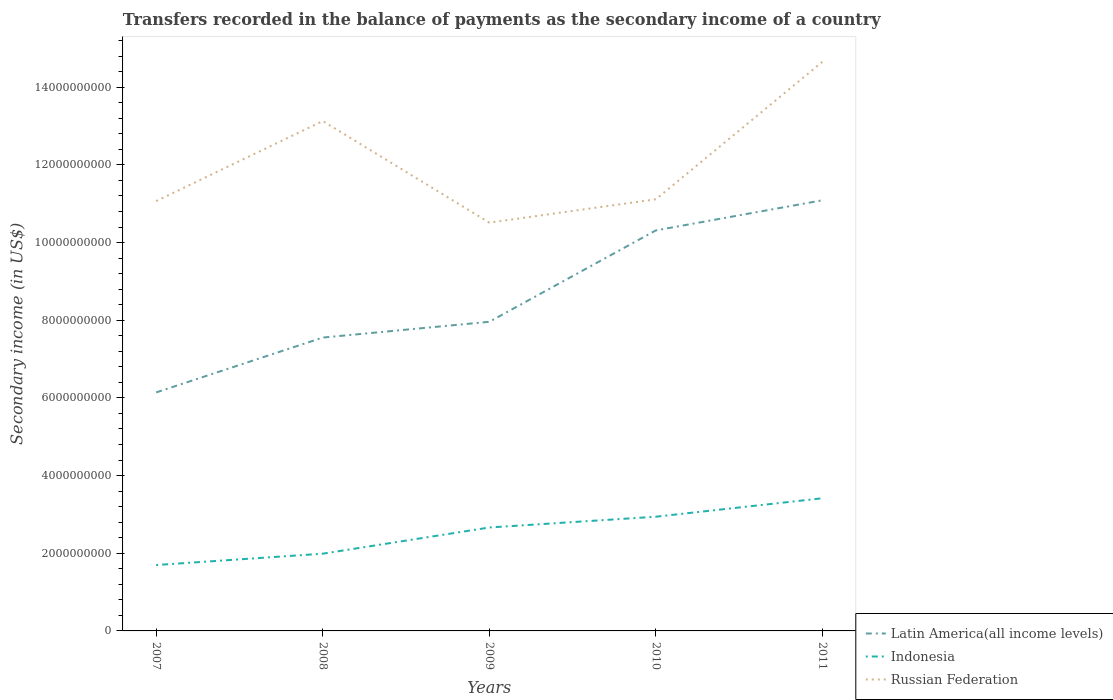Does the line corresponding to Indonesia intersect with the line corresponding to Latin America(all income levels)?
Ensure brevity in your answer.  No. Across all years, what is the maximum secondary income of in Latin America(all income levels)?
Ensure brevity in your answer.  6.14e+09. What is the total secondary income of in Indonesia in the graph?
Ensure brevity in your answer.  -9.67e+08. What is the difference between the highest and the second highest secondary income of in Russian Federation?
Your response must be concise. 4.14e+09. What is the difference between the highest and the lowest secondary income of in Indonesia?
Ensure brevity in your answer.  3. Is the secondary income of in Latin America(all income levels) strictly greater than the secondary income of in Russian Federation over the years?
Ensure brevity in your answer.  Yes. How many years are there in the graph?
Your answer should be very brief. 5. What is the title of the graph?
Offer a terse response. Transfers recorded in the balance of payments as the secondary income of a country. What is the label or title of the X-axis?
Ensure brevity in your answer.  Years. What is the label or title of the Y-axis?
Keep it short and to the point. Secondary income (in US$). What is the Secondary income (in US$) of Latin America(all income levels) in 2007?
Ensure brevity in your answer.  6.14e+09. What is the Secondary income (in US$) in Indonesia in 2007?
Provide a short and direct response. 1.70e+09. What is the Secondary income (in US$) in Russian Federation in 2007?
Offer a very short reply. 1.11e+1. What is the Secondary income (in US$) of Latin America(all income levels) in 2008?
Your response must be concise. 7.55e+09. What is the Secondary income (in US$) of Indonesia in 2008?
Ensure brevity in your answer.  1.99e+09. What is the Secondary income (in US$) of Russian Federation in 2008?
Offer a very short reply. 1.31e+1. What is the Secondary income (in US$) in Latin America(all income levels) in 2009?
Offer a terse response. 7.96e+09. What is the Secondary income (in US$) in Indonesia in 2009?
Your answer should be very brief. 2.66e+09. What is the Secondary income (in US$) of Russian Federation in 2009?
Your answer should be very brief. 1.05e+1. What is the Secondary income (in US$) in Latin America(all income levels) in 2010?
Provide a short and direct response. 1.03e+1. What is the Secondary income (in US$) of Indonesia in 2010?
Your response must be concise. 2.94e+09. What is the Secondary income (in US$) of Russian Federation in 2010?
Offer a very short reply. 1.11e+1. What is the Secondary income (in US$) of Latin America(all income levels) in 2011?
Provide a succinct answer. 1.11e+1. What is the Secondary income (in US$) in Indonesia in 2011?
Offer a very short reply. 3.42e+09. What is the Secondary income (in US$) of Russian Federation in 2011?
Offer a terse response. 1.47e+1. Across all years, what is the maximum Secondary income (in US$) of Latin America(all income levels)?
Keep it short and to the point. 1.11e+1. Across all years, what is the maximum Secondary income (in US$) of Indonesia?
Provide a succinct answer. 3.42e+09. Across all years, what is the maximum Secondary income (in US$) of Russian Federation?
Your answer should be compact. 1.47e+1. Across all years, what is the minimum Secondary income (in US$) of Latin America(all income levels)?
Your answer should be very brief. 6.14e+09. Across all years, what is the minimum Secondary income (in US$) in Indonesia?
Keep it short and to the point. 1.70e+09. Across all years, what is the minimum Secondary income (in US$) of Russian Federation?
Keep it short and to the point. 1.05e+1. What is the total Secondary income (in US$) of Latin America(all income levels) in the graph?
Provide a succinct answer. 4.31e+1. What is the total Secondary income (in US$) in Indonesia in the graph?
Ensure brevity in your answer.  1.27e+1. What is the total Secondary income (in US$) of Russian Federation in the graph?
Offer a terse response. 6.05e+1. What is the difference between the Secondary income (in US$) in Latin America(all income levels) in 2007 and that in 2008?
Your response must be concise. -1.41e+09. What is the difference between the Secondary income (in US$) in Indonesia in 2007 and that in 2008?
Provide a succinct answer. -2.92e+08. What is the difference between the Secondary income (in US$) in Russian Federation in 2007 and that in 2008?
Make the answer very short. -2.06e+09. What is the difference between the Secondary income (in US$) of Latin America(all income levels) in 2007 and that in 2009?
Provide a short and direct response. -1.82e+09. What is the difference between the Secondary income (in US$) of Indonesia in 2007 and that in 2009?
Provide a short and direct response. -9.67e+08. What is the difference between the Secondary income (in US$) of Russian Federation in 2007 and that in 2009?
Your response must be concise. 5.55e+08. What is the difference between the Secondary income (in US$) of Latin America(all income levels) in 2007 and that in 2010?
Your answer should be very brief. -4.17e+09. What is the difference between the Secondary income (in US$) of Indonesia in 2007 and that in 2010?
Offer a terse response. -1.24e+09. What is the difference between the Secondary income (in US$) in Russian Federation in 2007 and that in 2010?
Provide a short and direct response. -4.65e+07. What is the difference between the Secondary income (in US$) of Latin America(all income levels) in 2007 and that in 2011?
Ensure brevity in your answer.  -4.95e+09. What is the difference between the Secondary income (in US$) in Indonesia in 2007 and that in 2011?
Your answer should be very brief. -1.72e+09. What is the difference between the Secondary income (in US$) in Russian Federation in 2007 and that in 2011?
Offer a very short reply. -3.59e+09. What is the difference between the Secondary income (in US$) of Latin America(all income levels) in 2008 and that in 2009?
Offer a terse response. -4.06e+08. What is the difference between the Secondary income (in US$) in Indonesia in 2008 and that in 2009?
Provide a short and direct response. -6.75e+08. What is the difference between the Secondary income (in US$) in Russian Federation in 2008 and that in 2009?
Your response must be concise. 2.62e+09. What is the difference between the Secondary income (in US$) of Latin America(all income levels) in 2008 and that in 2010?
Offer a terse response. -2.76e+09. What is the difference between the Secondary income (in US$) in Indonesia in 2008 and that in 2010?
Offer a very short reply. -9.52e+08. What is the difference between the Secondary income (in US$) in Russian Federation in 2008 and that in 2010?
Your answer should be very brief. 2.01e+09. What is the difference between the Secondary income (in US$) of Latin America(all income levels) in 2008 and that in 2011?
Provide a succinct answer. -3.54e+09. What is the difference between the Secondary income (in US$) in Indonesia in 2008 and that in 2011?
Your answer should be compact. -1.43e+09. What is the difference between the Secondary income (in US$) of Russian Federation in 2008 and that in 2011?
Your answer should be very brief. -1.53e+09. What is the difference between the Secondary income (in US$) in Latin America(all income levels) in 2009 and that in 2010?
Offer a very short reply. -2.35e+09. What is the difference between the Secondary income (in US$) in Indonesia in 2009 and that in 2010?
Ensure brevity in your answer.  -2.78e+08. What is the difference between the Secondary income (in US$) in Russian Federation in 2009 and that in 2010?
Offer a terse response. -6.02e+08. What is the difference between the Secondary income (in US$) of Latin America(all income levels) in 2009 and that in 2011?
Give a very brief answer. -3.13e+09. What is the difference between the Secondary income (in US$) in Indonesia in 2009 and that in 2011?
Ensure brevity in your answer.  -7.53e+08. What is the difference between the Secondary income (in US$) in Russian Federation in 2009 and that in 2011?
Make the answer very short. -4.14e+09. What is the difference between the Secondary income (in US$) in Latin America(all income levels) in 2010 and that in 2011?
Offer a terse response. -7.75e+08. What is the difference between the Secondary income (in US$) of Indonesia in 2010 and that in 2011?
Your answer should be compact. -4.75e+08. What is the difference between the Secondary income (in US$) in Russian Federation in 2010 and that in 2011?
Keep it short and to the point. -3.54e+09. What is the difference between the Secondary income (in US$) in Latin America(all income levels) in 2007 and the Secondary income (in US$) in Indonesia in 2008?
Your response must be concise. 4.15e+09. What is the difference between the Secondary income (in US$) of Latin America(all income levels) in 2007 and the Secondary income (in US$) of Russian Federation in 2008?
Your answer should be compact. -6.99e+09. What is the difference between the Secondary income (in US$) in Indonesia in 2007 and the Secondary income (in US$) in Russian Federation in 2008?
Give a very brief answer. -1.14e+1. What is the difference between the Secondary income (in US$) in Latin America(all income levels) in 2007 and the Secondary income (in US$) in Indonesia in 2009?
Offer a terse response. 3.48e+09. What is the difference between the Secondary income (in US$) in Latin America(all income levels) in 2007 and the Secondary income (in US$) in Russian Federation in 2009?
Give a very brief answer. -4.37e+09. What is the difference between the Secondary income (in US$) in Indonesia in 2007 and the Secondary income (in US$) in Russian Federation in 2009?
Your answer should be compact. -8.82e+09. What is the difference between the Secondary income (in US$) of Latin America(all income levels) in 2007 and the Secondary income (in US$) of Indonesia in 2010?
Give a very brief answer. 3.20e+09. What is the difference between the Secondary income (in US$) in Latin America(all income levels) in 2007 and the Secondary income (in US$) in Russian Federation in 2010?
Ensure brevity in your answer.  -4.97e+09. What is the difference between the Secondary income (in US$) of Indonesia in 2007 and the Secondary income (in US$) of Russian Federation in 2010?
Provide a short and direct response. -9.42e+09. What is the difference between the Secondary income (in US$) in Latin America(all income levels) in 2007 and the Secondary income (in US$) in Indonesia in 2011?
Your answer should be compact. 2.73e+09. What is the difference between the Secondary income (in US$) in Latin America(all income levels) in 2007 and the Secondary income (in US$) in Russian Federation in 2011?
Offer a very short reply. -8.51e+09. What is the difference between the Secondary income (in US$) of Indonesia in 2007 and the Secondary income (in US$) of Russian Federation in 2011?
Provide a succinct answer. -1.30e+1. What is the difference between the Secondary income (in US$) of Latin America(all income levels) in 2008 and the Secondary income (in US$) of Indonesia in 2009?
Your answer should be compact. 4.89e+09. What is the difference between the Secondary income (in US$) in Latin America(all income levels) in 2008 and the Secondary income (in US$) in Russian Federation in 2009?
Your answer should be compact. -2.96e+09. What is the difference between the Secondary income (in US$) of Indonesia in 2008 and the Secondary income (in US$) of Russian Federation in 2009?
Offer a very short reply. -8.52e+09. What is the difference between the Secondary income (in US$) of Latin America(all income levels) in 2008 and the Secondary income (in US$) of Indonesia in 2010?
Give a very brief answer. 4.61e+09. What is the difference between the Secondary income (in US$) in Latin America(all income levels) in 2008 and the Secondary income (in US$) in Russian Federation in 2010?
Your response must be concise. -3.56e+09. What is the difference between the Secondary income (in US$) of Indonesia in 2008 and the Secondary income (in US$) of Russian Federation in 2010?
Give a very brief answer. -9.13e+09. What is the difference between the Secondary income (in US$) of Latin America(all income levels) in 2008 and the Secondary income (in US$) of Indonesia in 2011?
Provide a succinct answer. 4.14e+09. What is the difference between the Secondary income (in US$) of Latin America(all income levels) in 2008 and the Secondary income (in US$) of Russian Federation in 2011?
Provide a short and direct response. -7.10e+09. What is the difference between the Secondary income (in US$) of Indonesia in 2008 and the Secondary income (in US$) of Russian Federation in 2011?
Keep it short and to the point. -1.27e+1. What is the difference between the Secondary income (in US$) of Latin America(all income levels) in 2009 and the Secondary income (in US$) of Indonesia in 2010?
Your response must be concise. 5.02e+09. What is the difference between the Secondary income (in US$) in Latin America(all income levels) in 2009 and the Secondary income (in US$) in Russian Federation in 2010?
Offer a terse response. -3.15e+09. What is the difference between the Secondary income (in US$) of Indonesia in 2009 and the Secondary income (in US$) of Russian Federation in 2010?
Your answer should be very brief. -8.45e+09. What is the difference between the Secondary income (in US$) of Latin America(all income levels) in 2009 and the Secondary income (in US$) of Indonesia in 2011?
Provide a succinct answer. 4.54e+09. What is the difference between the Secondary income (in US$) of Latin America(all income levels) in 2009 and the Secondary income (in US$) of Russian Federation in 2011?
Your answer should be very brief. -6.70e+09. What is the difference between the Secondary income (in US$) of Indonesia in 2009 and the Secondary income (in US$) of Russian Federation in 2011?
Make the answer very short. -1.20e+1. What is the difference between the Secondary income (in US$) of Latin America(all income levels) in 2010 and the Secondary income (in US$) of Indonesia in 2011?
Offer a very short reply. 6.90e+09. What is the difference between the Secondary income (in US$) of Latin America(all income levels) in 2010 and the Secondary income (in US$) of Russian Federation in 2011?
Offer a terse response. -4.34e+09. What is the difference between the Secondary income (in US$) of Indonesia in 2010 and the Secondary income (in US$) of Russian Federation in 2011?
Offer a very short reply. -1.17e+1. What is the average Secondary income (in US$) in Latin America(all income levels) per year?
Make the answer very short. 8.61e+09. What is the average Secondary income (in US$) in Indonesia per year?
Provide a short and direct response. 2.54e+09. What is the average Secondary income (in US$) of Russian Federation per year?
Offer a very short reply. 1.21e+1. In the year 2007, what is the difference between the Secondary income (in US$) of Latin America(all income levels) and Secondary income (in US$) of Indonesia?
Ensure brevity in your answer.  4.44e+09. In the year 2007, what is the difference between the Secondary income (in US$) of Latin America(all income levels) and Secondary income (in US$) of Russian Federation?
Your answer should be compact. -4.93e+09. In the year 2007, what is the difference between the Secondary income (in US$) in Indonesia and Secondary income (in US$) in Russian Federation?
Your answer should be compact. -9.37e+09. In the year 2008, what is the difference between the Secondary income (in US$) in Latin America(all income levels) and Secondary income (in US$) in Indonesia?
Give a very brief answer. 5.56e+09. In the year 2008, what is the difference between the Secondary income (in US$) of Latin America(all income levels) and Secondary income (in US$) of Russian Federation?
Provide a short and direct response. -5.57e+09. In the year 2008, what is the difference between the Secondary income (in US$) of Indonesia and Secondary income (in US$) of Russian Federation?
Make the answer very short. -1.11e+1. In the year 2009, what is the difference between the Secondary income (in US$) in Latin America(all income levels) and Secondary income (in US$) in Indonesia?
Offer a terse response. 5.30e+09. In the year 2009, what is the difference between the Secondary income (in US$) of Latin America(all income levels) and Secondary income (in US$) of Russian Federation?
Give a very brief answer. -2.55e+09. In the year 2009, what is the difference between the Secondary income (in US$) of Indonesia and Secondary income (in US$) of Russian Federation?
Offer a very short reply. -7.85e+09. In the year 2010, what is the difference between the Secondary income (in US$) in Latin America(all income levels) and Secondary income (in US$) in Indonesia?
Provide a succinct answer. 7.37e+09. In the year 2010, what is the difference between the Secondary income (in US$) in Latin America(all income levels) and Secondary income (in US$) in Russian Federation?
Offer a terse response. -8.01e+08. In the year 2010, what is the difference between the Secondary income (in US$) of Indonesia and Secondary income (in US$) of Russian Federation?
Your response must be concise. -8.17e+09. In the year 2011, what is the difference between the Secondary income (in US$) of Latin America(all income levels) and Secondary income (in US$) of Indonesia?
Ensure brevity in your answer.  7.67e+09. In the year 2011, what is the difference between the Secondary income (in US$) in Latin America(all income levels) and Secondary income (in US$) in Russian Federation?
Give a very brief answer. -3.57e+09. In the year 2011, what is the difference between the Secondary income (in US$) of Indonesia and Secondary income (in US$) of Russian Federation?
Your response must be concise. -1.12e+1. What is the ratio of the Secondary income (in US$) in Latin America(all income levels) in 2007 to that in 2008?
Your answer should be compact. 0.81. What is the ratio of the Secondary income (in US$) of Indonesia in 2007 to that in 2008?
Your answer should be very brief. 0.85. What is the ratio of the Secondary income (in US$) in Russian Federation in 2007 to that in 2008?
Provide a short and direct response. 0.84. What is the ratio of the Secondary income (in US$) of Latin America(all income levels) in 2007 to that in 2009?
Provide a short and direct response. 0.77. What is the ratio of the Secondary income (in US$) of Indonesia in 2007 to that in 2009?
Keep it short and to the point. 0.64. What is the ratio of the Secondary income (in US$) in Russian Federation in 2007 to that in 2009?
Give a very brief answer. 1.05. What is the ratio of the Secondary income (in US$) of Latin America(all income levels) in 2007 to that in 2010?
Your answer should be very brief. 0.6. What is the ratio of the Secondary income (in US$) of Indonesia in 2007 to that in 2010?
Your response must be concise. 0.58. What is the ratio of the Secondary income (in US$) of Latin America(all income levels) in 2007 to that in 2011?
Ensure brevity in your answer.  0.55. What is the ratio of the Secondary income (in US$) in Indonesia in 2007 to that in 2011?
Give a very brief answer. 0.5. What is the ratio of the Secondary income (in US$) in Russian Federation in 2007 to that in 2011?
Give a very brief answer. 0.76. What is the ratio of the Secondary income (in US$) of Latin America(all income levels) in 2008 to that in 2009?
Provide a succinct answer. 0.95. What is the ratio of the Secondary income (in US$) of Indonesia in 2008 to that in 2009?
Your response must be concise. 0.75. What is the ratio of the Secondary income (in US$) in Russian Federation in 2008 to that in 2009?
Provide a succinct answer. 1.25. What is the ratio of the Secondary income (in US$) in Latin America(all income levels) in 2008 to that in 2010?
Provide a short and direct response. 0.73. What is the ratio of the Secondary income (in US$) of Indonesia in 2008 to that in 2010?
Ensure brevity in your answer.  0.68. What is the ratio of the Secondary income (in US$) in Russian Federation in 2008 to that in 2010?
Provide a succinct answer. 1.18. What is the ratio of the Secondary income (in US$) in Latin America(all income levels) in 2008 to that in 2011?
Make the answer very short. 0.68. What is the ratio of the Secondary income (in US$) in Indonesia in 2008 to that in 2011?
Your answer should be very brief. 0.58. What is the ratio of the Secondary income (in US$) in Russian Federation in 2008 to that in 2011?
Make the answer very short. 0.9. What is the ratio of the Secondary income (in US$) in Latin America(all income levels) in 2009 to that in 2010?
Ensure brevity in your answer.  0.77. What is the ratio of the Secondary income (in US$) of Indonesia in 2009 to that in 2010?
Provide a short and direct response. 0.91. What is the ratio of the Secondary income (in US$) in Russian Federation in 2009 to that in 2010?
Ensure brevity in your answer.  0.95. What is the ratio of the Secondary income (in US$) in Latin America(all income levels) in 2009 to that in 2011?
Provide a short and direct response. 0.72. What is the ratio of the Secondary income (in US$) of Indonesia in 2009 to that in 2011?
Provide a short and direct response. 0.78. What is the ratio of the Secondary income (in US$) in Russian Federation in 2009 to that in 2011?
Your answer should be compact. 0.72. What is the ratio of the Secondary income (in US$) in Latin America(all income levels) in 2010 to that in 2011?
Your response must be concise. 0.93. What is the ratio of the Secondary income (in US$) of Indonesia in 2010 to that in 2011?
Ensure brevity in your answer.  0.86. What is the ratio of the Secondary income (in US$) of Russian Federation in 2010 to that in 2011?
Your answer should be compact. 0.76. What is the difference between the highest and the second highest Secondary income (in US$) in Latin America(all income levels)?
Provide a succinct answer. 7.75e+08. What is the difference between the highest and the second highest Secondary income (in US$) of Indonesia?
Provide a short and direct response. 4.75e+08. What is the difference between the highest and the second highest Secondary income (in US$) of Russian Federation?
Keep it short and to the point. 1.53e+09. What is the difference between the highest and the lowest Secondary income (in US$) of Latin America(all income levels)?
Your response must be concise. 4.95e+09. What is the difference between the highest and the lowest Secondary income (in US$) in Indonesia?
Provide a short and direct response. 1.72e+09. What is the difference between the highest and the lowest Secondary income (in US$) of Russian Federation?
Make the answer very short. 4.14e+09. 